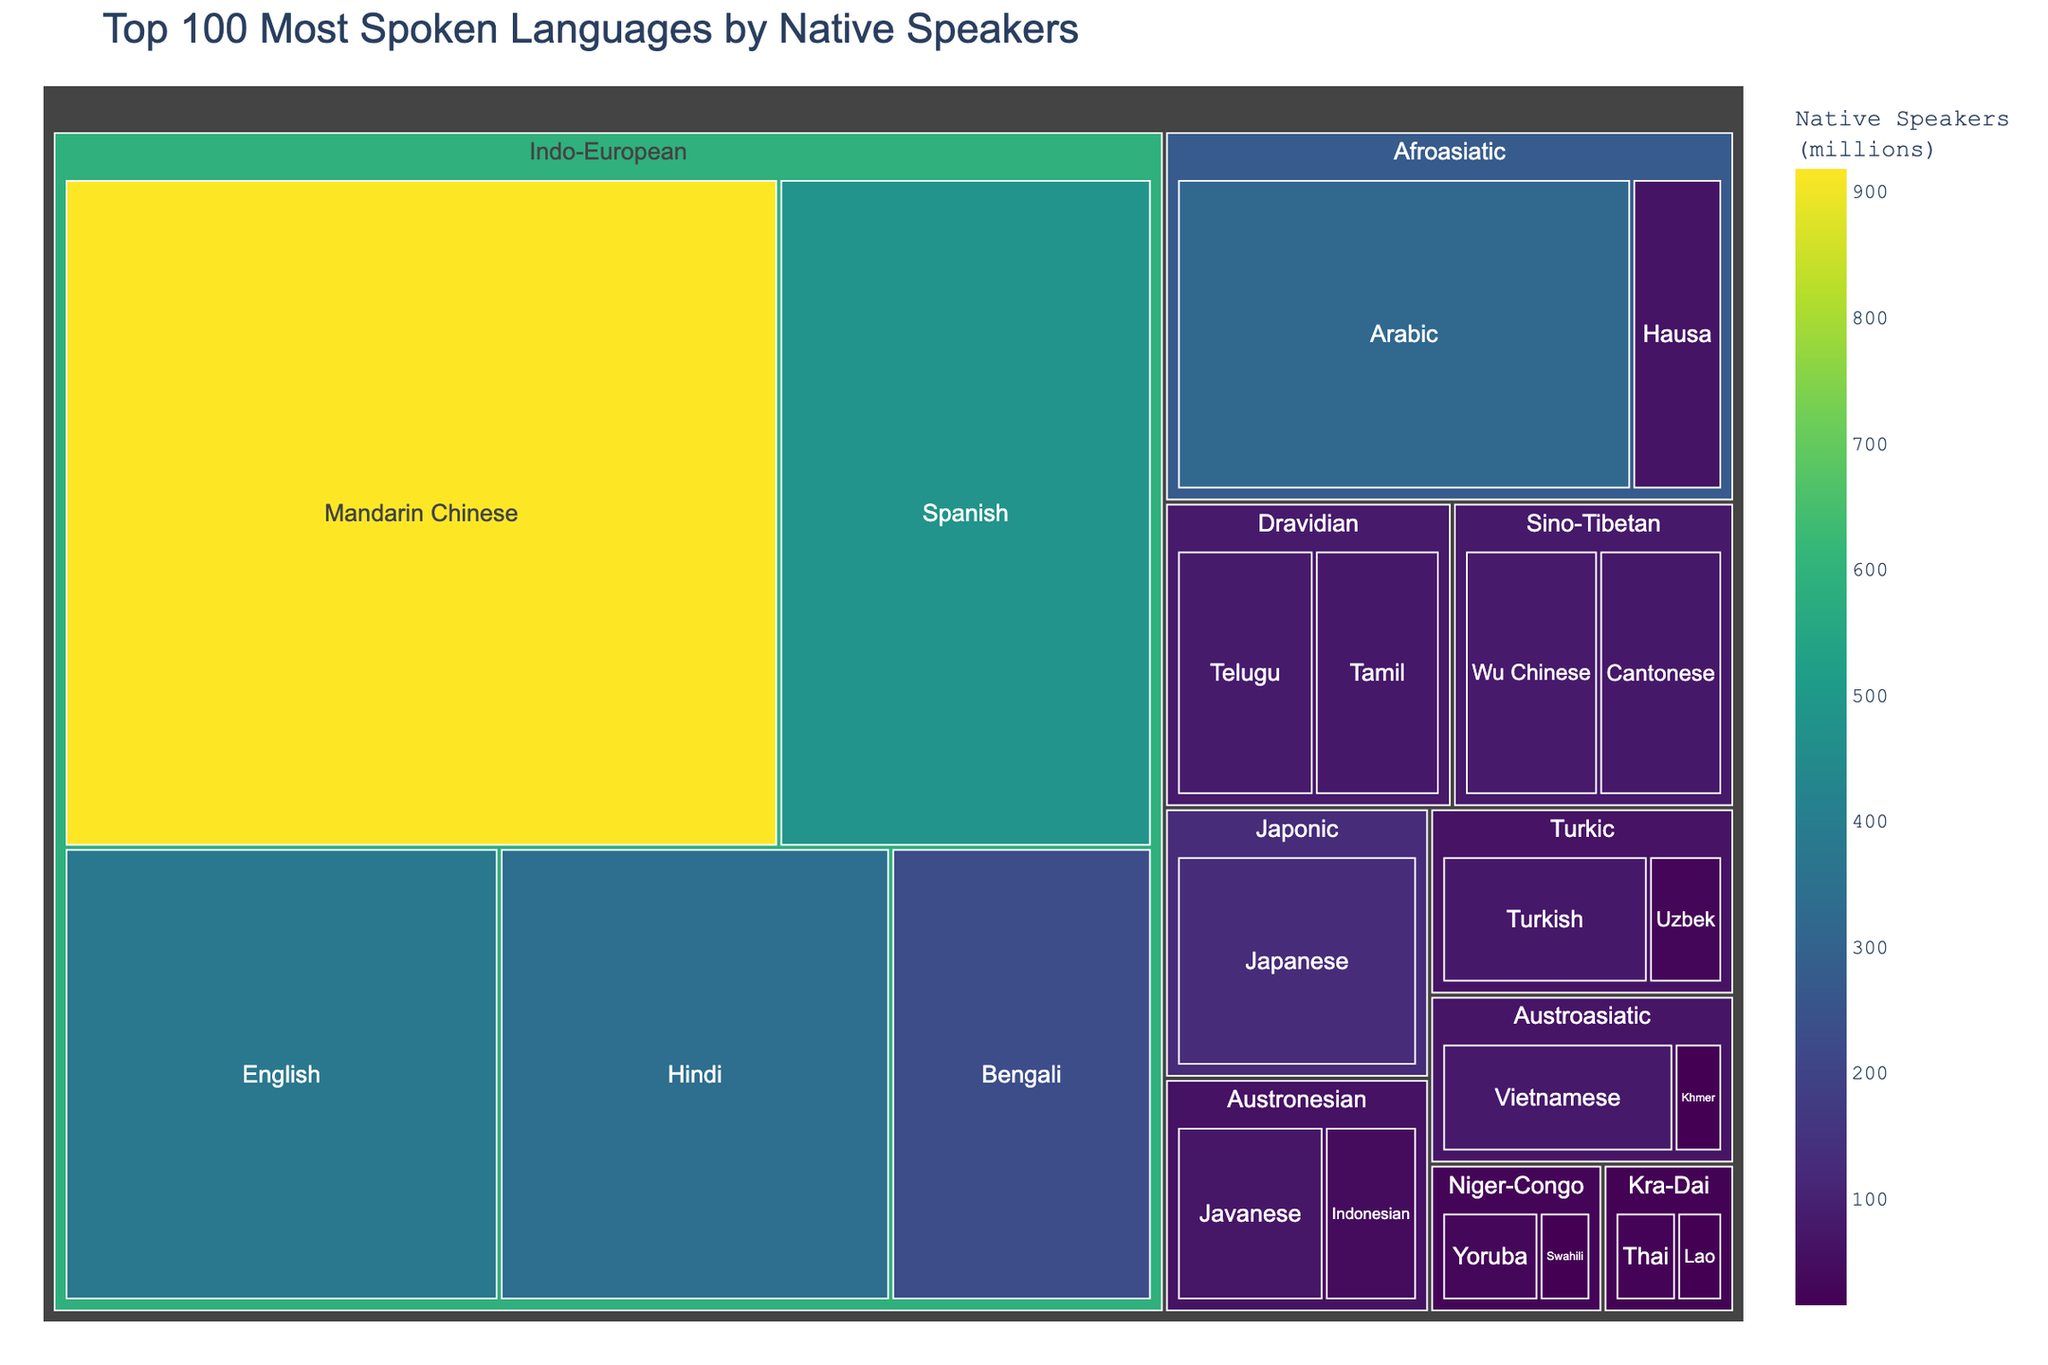What is the title of the figure? The title of the figure is usually displayed at the top of a plot. This title provides a brief description of what the figure represents.
Answer: Top 100 Most Spoken Languages by Native Speakers Which language has the highest number of native speakers? By looking at the size and color of the boxes in the treemap, the largest and darkest box indicates the language with the highest number of native speakers.
Answer: Mandarin Chinese What language family does Arabic belong to? The treemap categorizes languages by family, and by locating Arabic, you can see the family it belongs to according to the hierarchical structure.
Answer: Afroasiatic How many native speakers are there for the Japanese language? Hovering over or identifying the Japanese box will display its native speakers' count.
Answer: 128 million What is the combined number of native speakers for Spanish and English? To find the combined number, sum the individual native speaker counts of Spanish and English, both of which are available from hovering over or reading the respective boxes. Spanish has 480 million and English has 379 million. Therefore, 480 + 379 = 859 million.
Answer: 859 million Which language families contain more than two languages in the figure? By examining the number of boxes within each language family category, identify which families have more than two languages.
Answer: Indo-European, Sino-Tibetan, Afroasiatic, Niger-Congo Compare the number of native speakers of Tamil and Telugu. Which language has more? By locating the boxes for Tamil and Telugu within their language family, compare their respective sizes or hover over each to see the number of native speakers. Tamil has 75 million, and Telugu has 82 million, so Telugu has more.
Answer: Telugu Which language in the figure has the smallest number of native speakers? The smallest and lightest colored box in the treemap represents the language with the smallest number of native speakers.
Answer: Lao What is the total number of native speakers for the Afroasiatic languages listed? Sum the number of native speakers for each Afroasiatic language (Arabic and Hausa). Arabic: 315 million, Hausa: 63 million. Therefore, 315 + 63 = 378 million.
Answer: 378 million Which language family has the most spoken language listed in this figure? By identifying the family that Mandarin Chinese belongs to (the language with the highest number of native speakers), you can answer which family it is categorized under in the figure.
Answer: Indo-European 